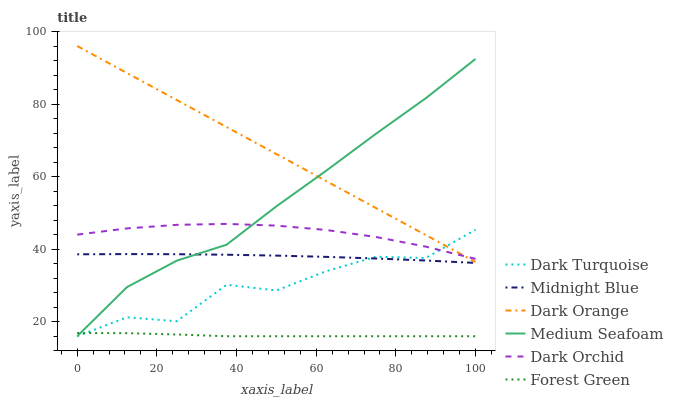Does Midnight Blue have the minimum area under the curve?
Answer yes or no. No. Does Midnight Blue have the maximum area under the curve?
Answer yes or no. No. Is Midnight Blue the smoothest?
Answer yes or no. No. Is Midnight Blue the roughest?
Answer yes or no. No. Does Midnight Blue have the lowest value?
Answer yes or no. No. Does Midnight Blue have the highest value?
Answer yes or no. No. Is Midnight Blue less than Dark Orchid?
Answer yes or no. Yes. Is Dark Orange greater than Forest Green?
Answer yes or no. Yes. Does Midnight Blue intersect Dark Orchid?
Answer yes or no. No. 